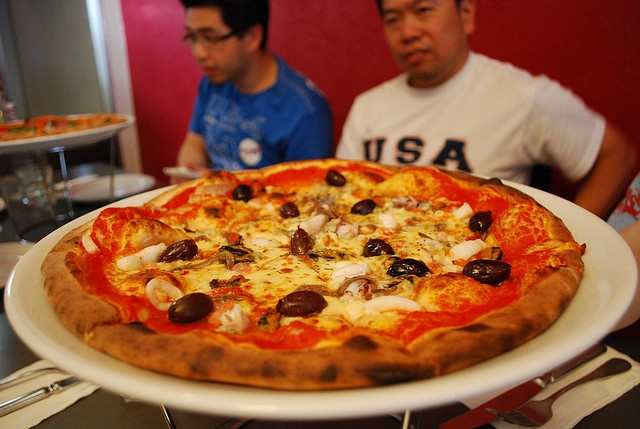Describe the objects in this image and their specific colors. I can see dining table in black, brown, maroon, red, and orange tones, pizza in black, brown, red, and orange tones, people in black, tan, and maroon tones, people in black, navy, maroon, and brown tones, and fork in black, maroon, tan, and gray tones in this image. 